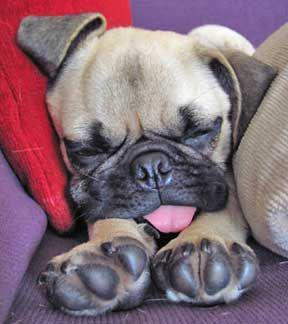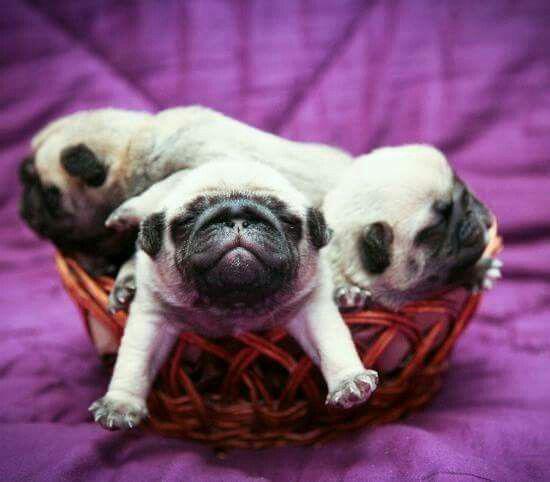The first image is the image on the left, the second image is the image on the right. Evaluate the accuracy of this statement regarding the images: "At least one of the pugs is wearing something on its head.". Is it true? Answer yes or no. No. The first image is the image on the left, the second image is the image on the right. For the images shown, is this caption "There is a pug wearing something decorative and cute on his head." true? Answer yes or no. No. 